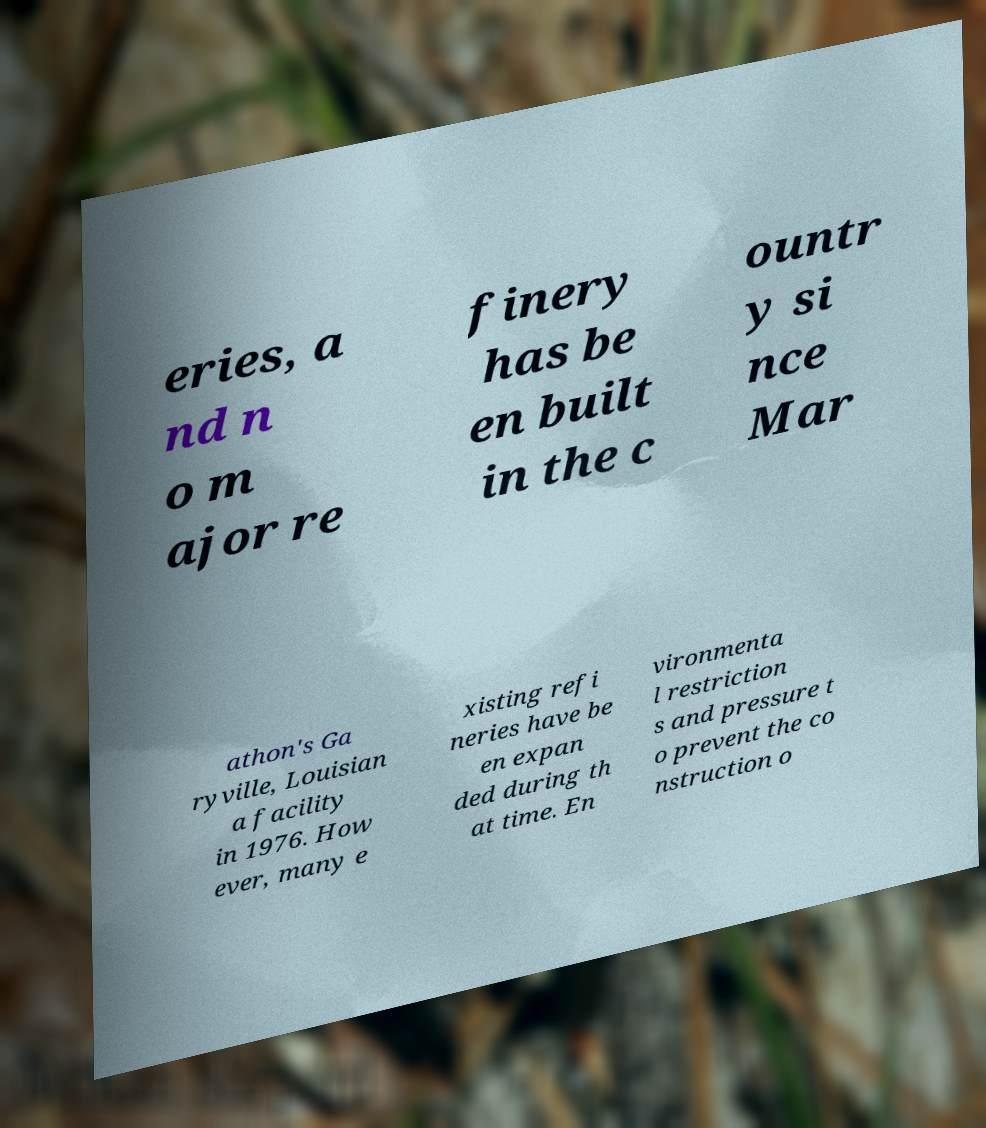I need the written content from this picture converted into text. Can you do that? eries, a nd n o m ajor re finery has be en built in the c ountr y si nce Mar athon's Ga ryville, Louisian a facility in 1976. How ever, many e xisting refi neries have be en expan ded during th at time. En vironmenta l restriction s and pressure t o prevent the co nstruction o 